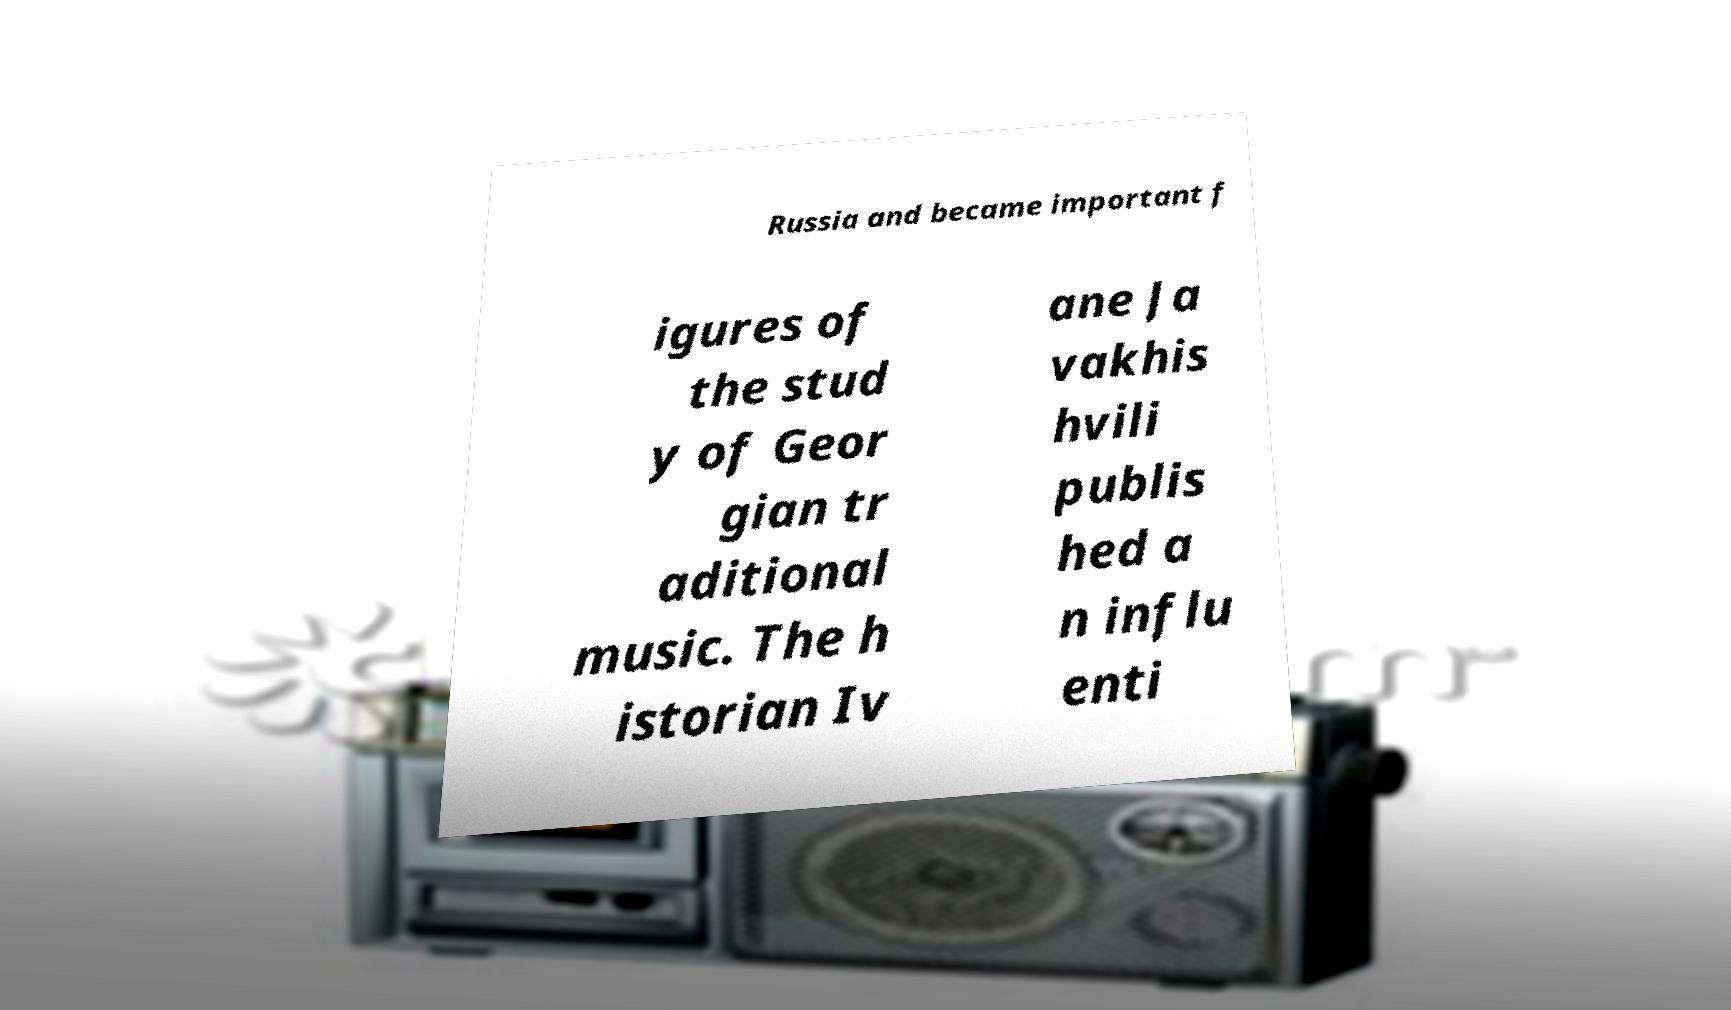Can you read and provide the text displayed in the image?This photo seems to have some interesting text. Can you extract and type it out for me? Russia and became important f igures of the stud y of Geor gian tr aditional music. The h istorian Iv ane Ja vakhis hvili publis hed a n influ enti 